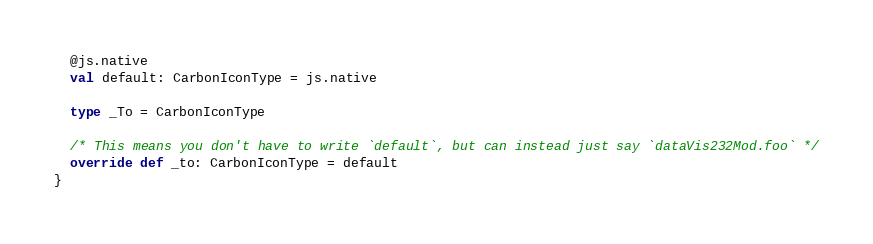<code> <loc_0><loc_0><loc_500><loc_500><_Scala_>  @js.native
  val default: CarbonIconType = js.native
  
  type _To = CarbonIconType
  
  /* This means you don't have to write `default`, but can instead just say `dataVis232Mod.foo` */
  override def _to: CarbonIconType = default
}
</code> 